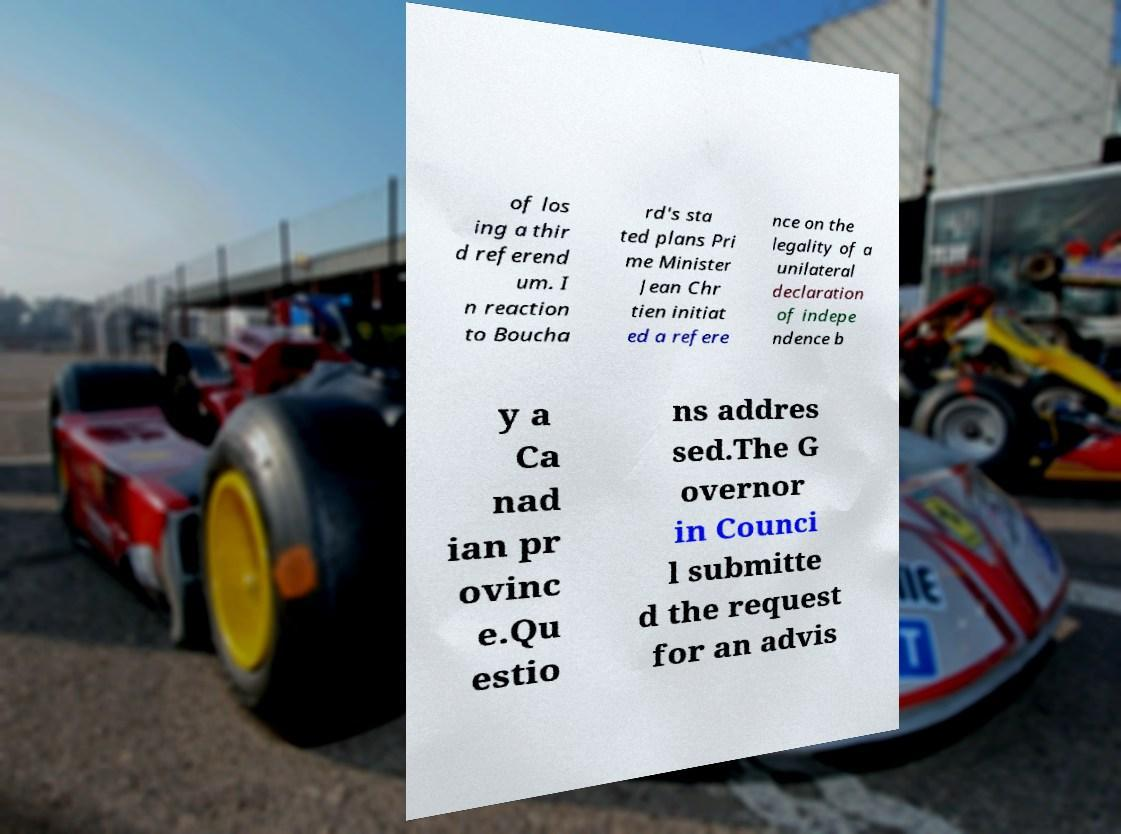Could you assist in decoding the text presented in this image and type it out clearly? of los ing a thir d referend um. I n reaction to Boucha rd's sta ted plans Pri me Minister Jean Chr tien initiat ed a refere nce on the legality of a unilateral declaration of indepe ndence b y a Ca nad ian pr ovinc e.Qu estio ns addres sed.The G overnor in Counci l submitte d the request for an advis 